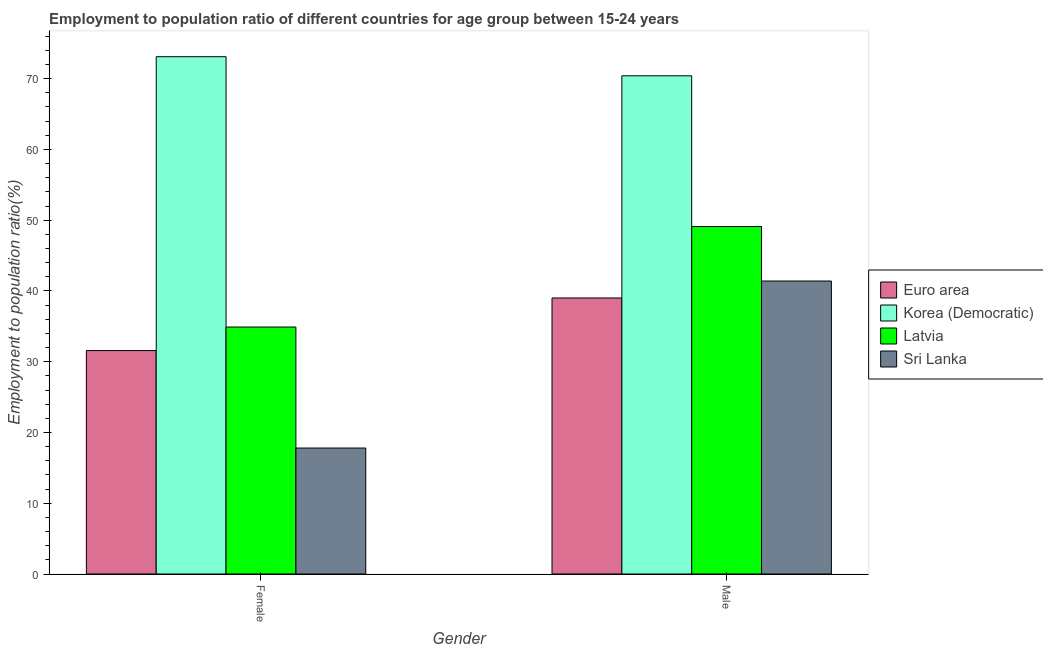How many different coloured bars are there?
Your response must be concise. 4. How many groups of bars are there?
Your answer should be very brief. 2. Are the number of bars per tick equal to the number of legend labels?
Ensure brevity in your answer.  Yes. What is the label of the 1st group of bars from the left?
Offer a terse response. Female. What is the employment to population ratio(male) in Euro area?
Provide a short and direct response. 39. Across all countries, what is the maximum employment to population ratio(male)?
Your response must be concise. 70.4. Across all countries, what is the minimum employment to population ratio(female)?
Provide a short and direct response. 17.8. In which country was the employment to population ratio(female) maximum?
Make the answer very short. Korea (Democratic). In which country was the employment to population ratio(male) minimum?
Give a very brief answer. Euro area. What is the total employment to population ratio(female) in the graph?
Your answer should be compact. 157.37. What is the difference between the employment to population ratio(male) in Latvia and that in Korea (Democratic)?
Offer a terse response. -21.3. What is the difference between the employment to population ratio(female) in Sri Lanka and the employment to population ratio(male) in Euro area?
Offer a terse response. -21.2. What is the average employment to population ratio(female) per country?
Give a very brief answer. 39.34. What is the difference between the employment to population ratio(male) and employment to population ratio(female) in Latvia?
Offer a very short reply. 14.2. In how many countries, is the employment to population ratio(female) greater than 6 %?
Provide a succinct answer. 4. What is the ratio of the employment to population ratio(male) in Korea (Democratic) to that in Euro area?
Give a very brief answer. 1.8. What does the 4th bar from the left in Female represents?
Provide a short and direct response. Sri Lanka. What does the 3rd bar from the right in Female represents?
Ensure brevity in your answer.  Korea (Democratic). How many bars are there?
Provide a short and direct response. 8. Are all the bars in the graph horizontal?
Give a very brief answer. No. How many countries are there in the graph?
Make the answer very short. 4. What is the difference between two consecutive major ticks on the Y-axis?
Offer a terse response. 10. Are the values on the major ticks of Y-axis written in scientific E-notation?
Keep it short and to the point. No. Does the graph contain any zero values?
Give a very brief answer. No. How are the legend labels stacked?
Your answer should be compact. Vertical. What is the title of the graph?
Make the answer very short. Employment to population ratio of different countries for age group between 15-24 years. What is the Employment to population ratio(%) in Euro area in Female?
Provide a short and direct response. 31.57. What is the Employment to population ratio(%) in Korea (Democratic) in Female?
Keep it short and to the point. 73.1. What is the Employment to population ratio(%) in Latvia in Female?
Make the answer very short. 34.9. What is the Employment to population ratio(%) of Sri Lanka in Female?
Your answer should be very brief. 17.8. What is the Employment to population ratio(%) in Euro area in Male?
Ensure brevity in your answer.  39. What is the Employment to population ratio(%) of Korea (Democratic) in Male?
Your answer should be compact. 70.4. What is the Employment to population ratio(%) in Latvia in Male?
Offer a very short reply. 49.1. What is the Employment to population ratio(%) in Sri Lanka in Male?
Provide a succinct answer. 41.4. Across all Gender, what is the maximum Employment to population ratio(%) in Euro area?
Give a very brief answer. 39. Across all Gender, what is the maximum Employment to population ratio(%) in Korea (Democratic)?
Your answer should be compact. 73.1. Across all Gender, what is the maximum Employment to population ratio(%) of Latvia?
Make the answer very short. 49.1. Across all Gender, what is the maximum Employment to population ratio(%) in Sri Lanka?
Your response must be concise. 41.4. Across all Gender, what is the minimum Employment to population ratio(%) of Euro area?
Offer a terse response. 31.57. Across all Gender, what is the minimum Employment to population ratio(%) of Korea (Democratic)?
Ensure brevity in your answer.  70.4. Across all Gender, what is the minimum Employment to population ratio(%) in Latvia?
Your answer should be compact. 34.9. Across all Gender, what is the minimum Employment to population ratio(%) of Sri Lanka?
Provide a short and direct response. 17.8. What is the total Employment to population ratio(%) in Euro area in the graph?
Ensure brevity in your answer.  70.58. What is the total Employment to population ratio(%) in Korea (Democratic) in the graph?
Your answer should be very brief. 143.5. What is the total Employment to population ratio(%) of Sri Lanka in the graph?
Your answer should be compact. 59.2. What is the difference between the Employment to population ratio(%) in Euro area in Female and that in Male?
Make the answer very short. -7.43. What is the difference between the Employment to population ratio(%) of Sri Lanka in Female and that in Male?
Your answer should be compact. -23.6. What is the difference between the Employment to population ratio(%) of Euro area in Female and the Employment to population ratio(%) of Korea (Democratic) in Male?
Provide a short and direct response. -38.83. What is the difference between the Employment to population ratio(%) in Euro area in Female and the Employment to population ratio(%) in Latvia in Male?
Keep it short and to the point. -17.53. What is the difference between the Employment to population ratio(%) in Euro area in Female and the Employment to population ratio(%) in Sri Lanka in Male?
Provide a short and direct response. -9.83. What is the difference between the Employment to population ratio(%) in Korea (Democratic) in Female and the Employment to population ratio(%) in Latvia in Male?
Make the answer very short. 24. What is the difference between the Employment to population ratio(%) in Korea (Democratic) in Female and the Employment to population ratio(%) in Sri Lanka in Male?
Your answer should be very brief. 31.7. What is the difference between the Employment to population ratio(%) of Latvia in Female and the Employment to population ratio(%) of Sri Lanka in Male?
Provide a short and direct response. -6.5. What is the average Employment to population ratio(%) in Euro area per Gender?
Give a very brief answer. 35.29. What is the average Employment to population ratio(%) in Korea (Democratic) per Gender?
Make the answer very short. 71.75. What is the average Employment to population ratio(%) of Sri Lanka per Gender?
Make the answer very short. 29.6. What is the difference between the Employment to population ratio(%) in Euro area and Employment to population ratio(%) in Korea (Democratic) in Female?
Offer a terse response. -41.53. What is the difference between the Employment to population ratio(%) of Euro area and Employment to population ratio(%) of Latvia in Female?
Make the answer very short. -3.33. What is the difference between the Employment to population ratio(%) of Euro area and Employment to population ratio(%) of Sri Lanka in Female?
Your answer should be compact. 13.77. What is the difference between the Employment to population ratio(%) of Korea (Democratic) and Employment to population ratio(%) of Latvia in Female?
Your answer should be compact. 38.2. What is the difference between the Employment to population ratio(%) of Korea (Democratic) and Employment to population ratio(%) of Sri Lanka in Female?
Make the answer very short. 55.3. What is the difference between the Employment to population ratio(%) in Euro area and Employment to population ratio(%) in Korea (Democratic) in Male?
Your answer should be very brief. -31.4. What is the difference between the Employment to population ratio(%) of Euro area and Employment to population ratio(%) of Latvia in Male?
Make the answer very short. -10.1. What is the difference between the Employment to population ratio(%) of Euro area and Employment to population ratio(%) of Sri Lanka in Male?
Provide a succinct answer. -2.4. What is the difference between the Employment to population ratio(%) in Korea (Democratic) and Employment to population ratio(%) in Latvia in Male?
Provide a short and direct response. 21.3. What is the difference between the Employment to population ratio(%) in Korea (Democratic) and Employment to population ratio(%) in Sri Lanka in Male?
Offer a terse response. 29. What is the ratio of the Employment to population ratio(%) in Euro area in Female to that in Male?
Give a very brief answer. 0.81. What is the ratio of the Employment to population ratio(%) in Korea (Democratic) in Female to that in Male?
Your response must be concise. 1.04. What is the ratio of the Employment to population ratio(%) in Latvia in Female to that in Male?
Give a very brief answer. 0.71. What is the ratio of the Employment to population ratio(%) in Sri Lanka in Female to that in Male?
Provide a succinct answer. 0.43. What is the difference between the highest and the second highest Employment to population ratio(%) of Euro area?
Keep it short and to the point. 7.43. What is the difference between the highest and the second highest Employment to population ratio(%) in Sri Lanka?
Give a very brief answer. 23.6. What is the difference between the highest and the lowest Employment to population ratio(%) of Euro area?
Your answer should be compact. 7.43. What is the difference between the highest and the lowest Employment to population ratio(%) in Sri Lanka?
Ensure brevity in your answer.  23.6. 